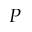Convert formula to latex. <formula><loc_0><loc_0><loc_500><loc_500>P</formula> 